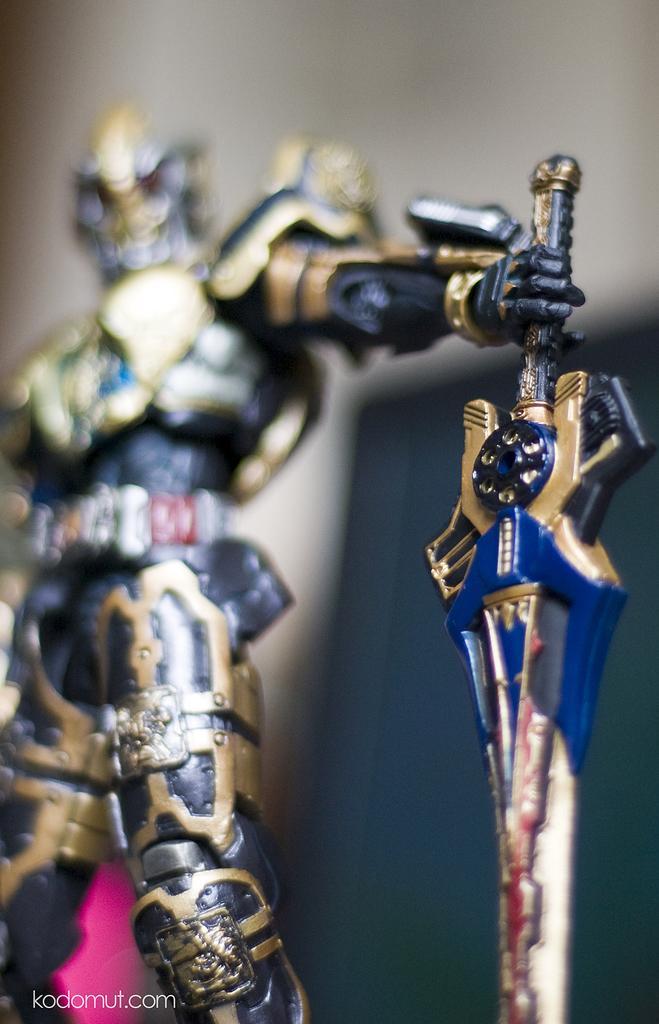Please provide a concise description of this image. In the image there is a statue of person with armour and shield and holding a sword. 